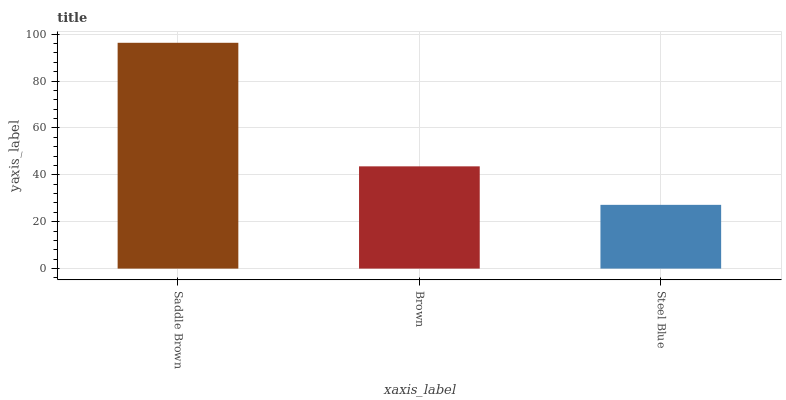Is Steel Blue the minimum?
Answer yes or no. Yes. Is Saddle Brown the maximum?
Answer yes or no. Yes. Is Brown the minimum?
Answer yes or no. No. Is Brown the maximum?
Answer yes or no. No. Is Saddle Brown greater than Brown?
Answer yes or no. Yes. Is Brown less than Saddle Brown?
Answer yes or no. Yes. Is Brown greater than Saddle Brown?
Answer yes or no. No. Is Saddle Brown less than Brown?
Answer yes or no. No. Is Brown the high median?
Answer yes or no. Yes. Is Brown the low median?
Answer yes or no. Yes. Is Saddle Brown the high median?
Answer yes or no. No. Is Steel Blue the low median?
Answer yes or no. No. 